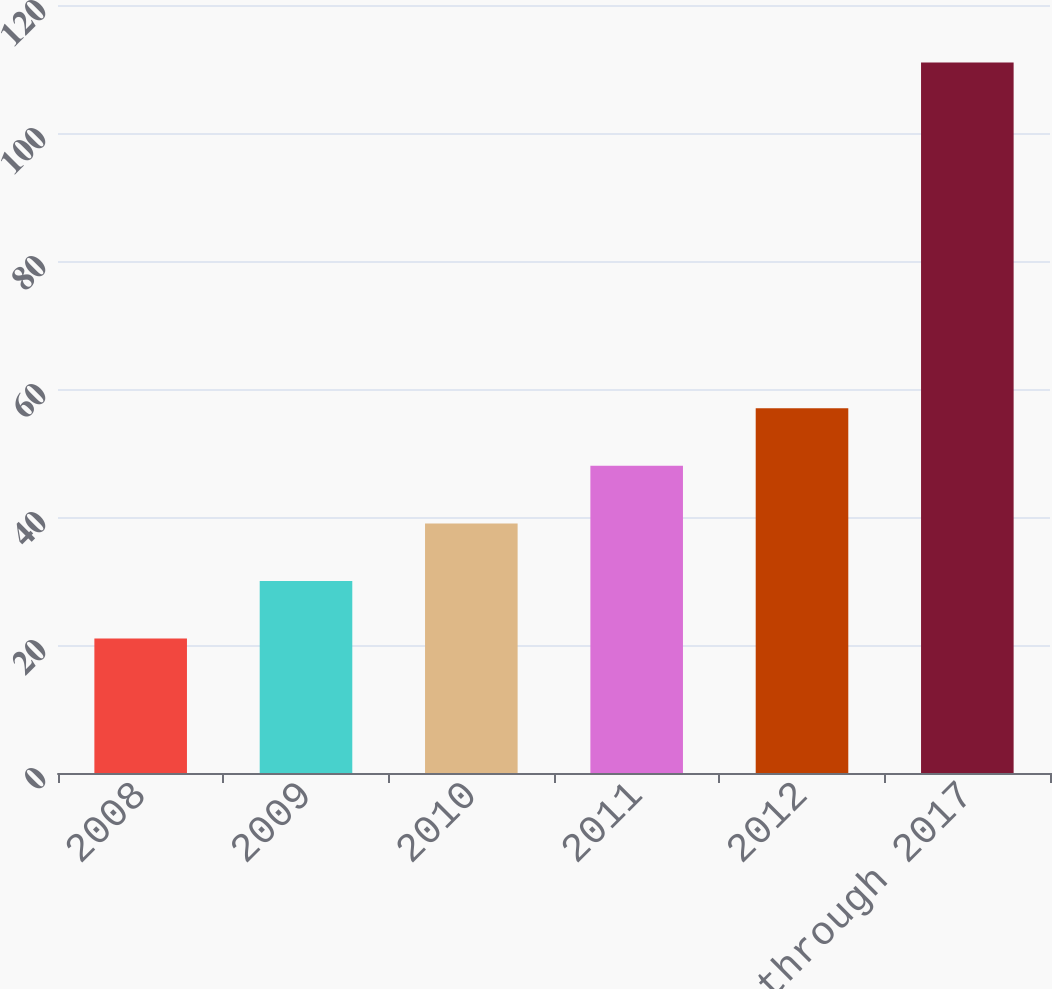Convert chart to OTSL. <chart><loc_0><loc_0><loc_500><loc_500><bar_chart><fcel>2008<fcel>2009<fcel>2010<fcel>2011<fcel>2012<fcel>2013 through 2017<nl><fcel>21<fcel>30<fcel>39<fcel>48<fcel>57<fcel>111<nl></chart> 